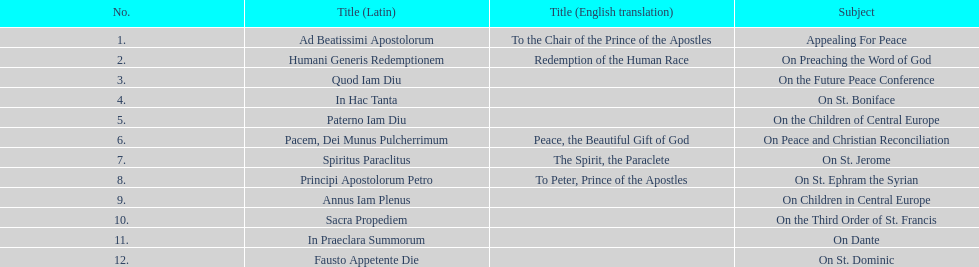In how many encyclopedias can one find subjects that pertain particularly to children? 2. 